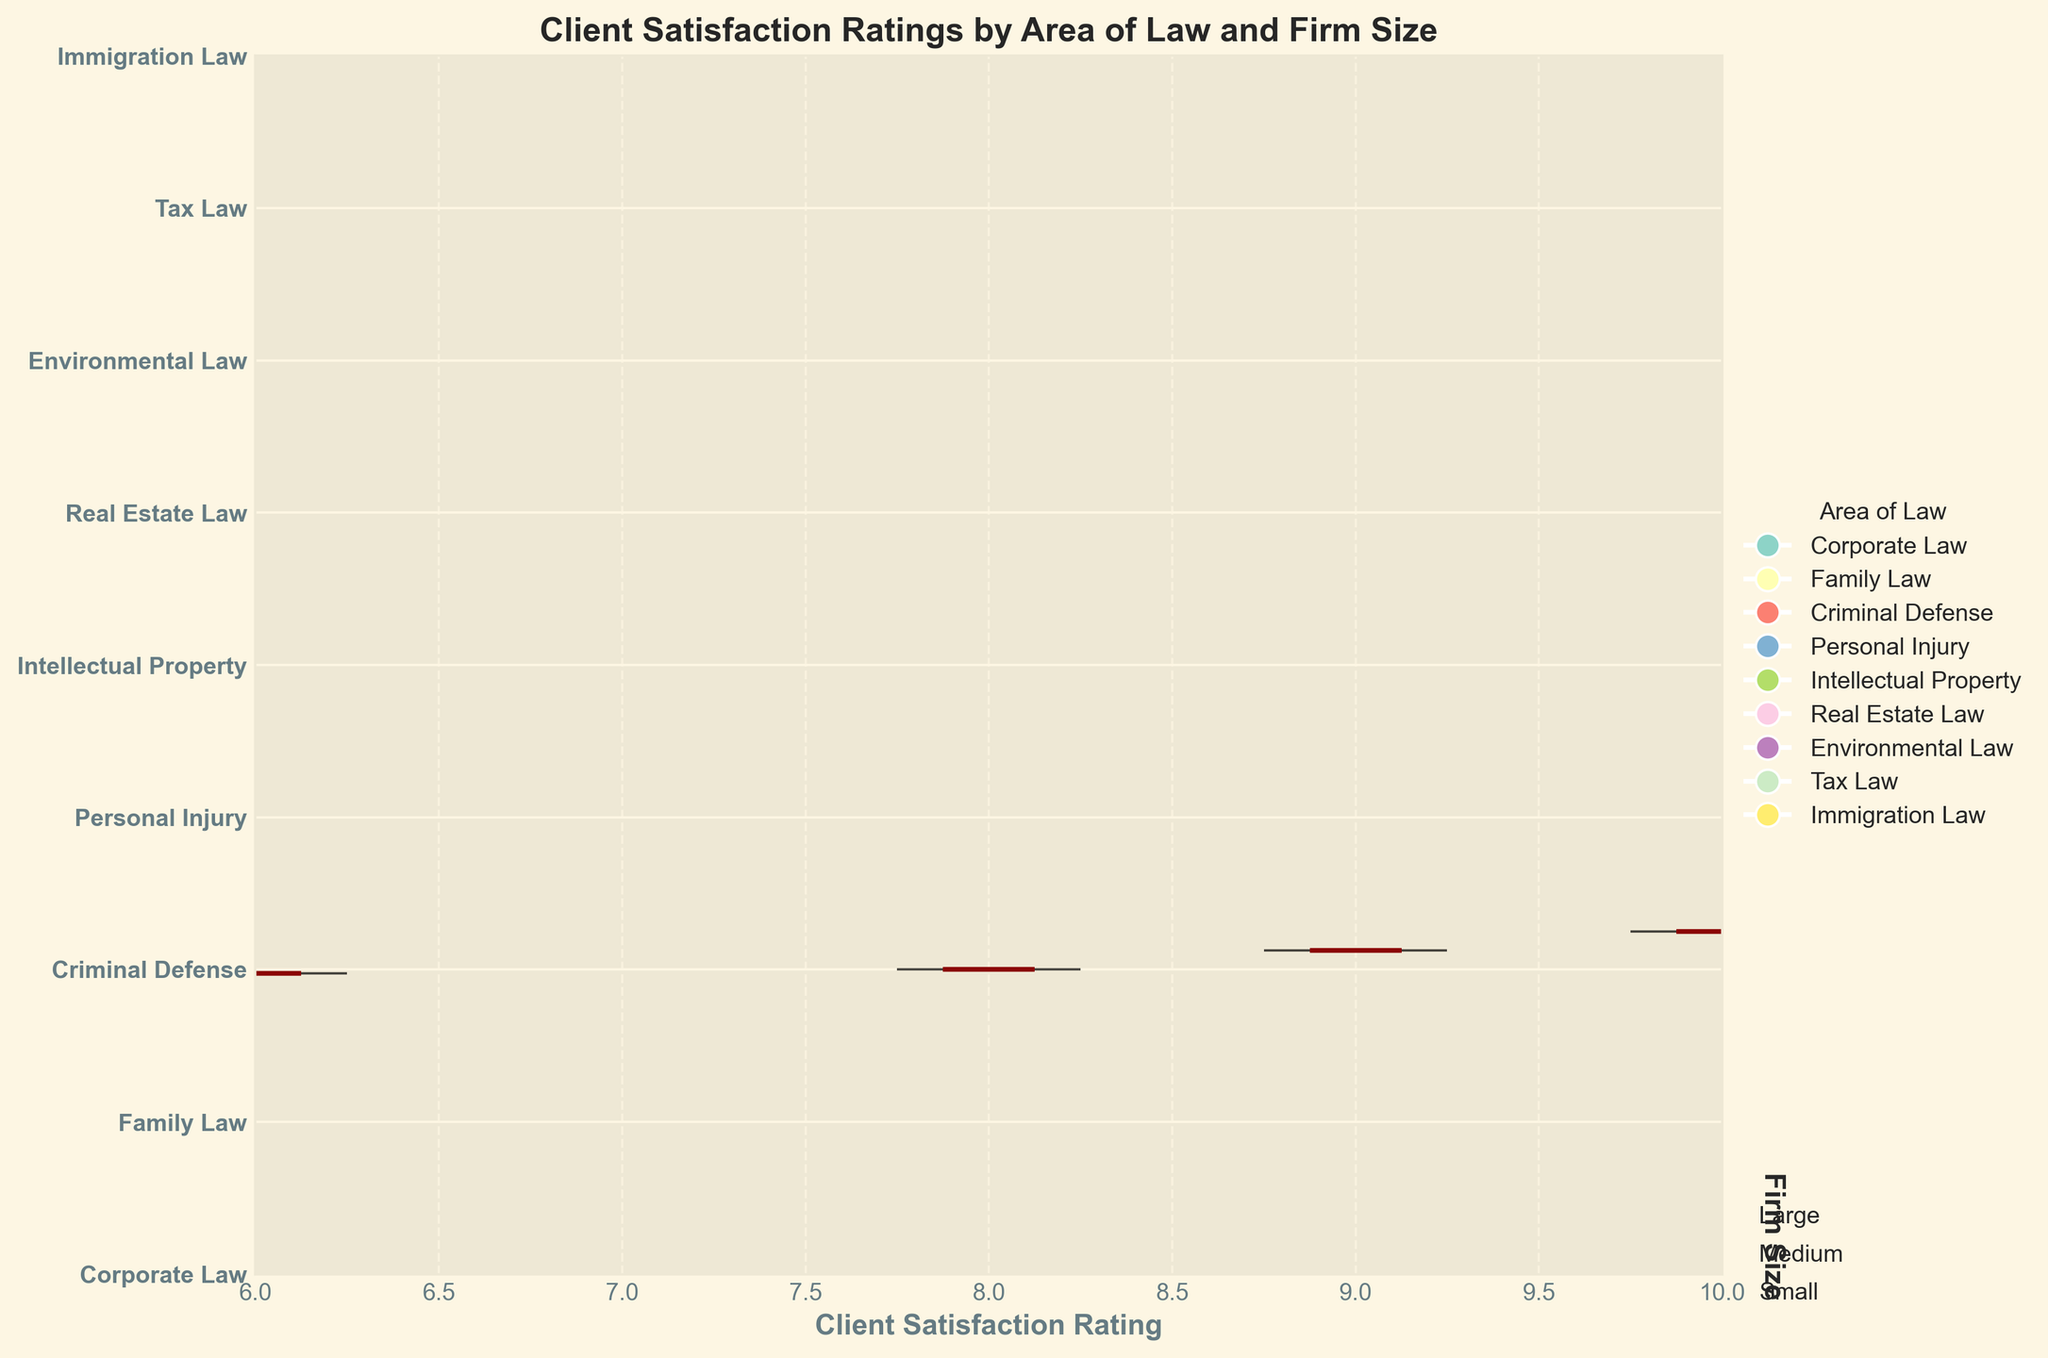What is the title of the figure? The title of the figure is located at the top center. It reads "Client Satisfaction Ratings by Area of Law and Firm Size".
Answer: Client Satisfaction Ratings by Area of Law and Firm Size What does the x-axis represent? The x-axis label is indicated at the bottom of the chart. It represents "Client Satisfaction Rating".
Answer: Client Satisfaction Rating Which area of law has the highest median client satisfaction rating for large firms? At the bottom segment of each area, there is a median indicator. For large firms, Criminal Defense shows the highest median satisfaction rating at 9.0.
Answer: Criminal Defense How many different colors are used in the figure, and what do they represent? By referencing the violin plots, each uniquely colored segment corresponds to a different area of law. Counting these, there are 10 distinct colors used in total. Each color represents a specific area of law as explained by the legend on the right side.
Answer: 10 What is the general trend in client satisfaction from small to large firms across all areas of law? Each group of violins shows three sizes (small, medium, large) moving from left to right. For almost all areas of law, the rating increases as the firm size increases, indicating a general trend of higher satisfaction with larger firms.
Answer: Increasing Compare the client satisfaction rating medians between Family Law and Tax Law for medium-sized firms. The medians for Family Law and Tax Law can be identified by the marks on their respective violin plots. Family Law has a median satisfaction rating of 7.4, while Tax Law has a median of 7.3 for medium-sized firms, making Family Law slightly higher.
Answer: Family Law What is the difference in client satisfaction rating between small and large firms in Real Estate Law? For Real Estate Law, the small firm median is 6.9, and the large firm median is 8.1. The difference is calculated as 8.1 - 6.9.
Answer: 1.2 Which area of law shows the least variation in client satisfaction ratings across all firm sizes? The variation can be visually assessed by the width and spread of each violin plot. Corporate Law, with relatively narrow and uniformly distributed violins across the sizes, shows the least variation.
Answer: Corporate Law What are the specific client satisfaction ratings for Intellectual Property in small, medium, and large firms? The data points directly refer to Intellectual Property: 7.8 for small firms, 8.3 for medium firms, and 8.8 for large firms.
Answer: 7.8, 8.3, 8.8 Is there any area of law where medium-sized firms have the highest client satisfaction ratings compared to small and large firms? By comparing all medians between small, medium, and large firm sizes in each area of law, it is noticeable that no area of law has a higher rating for medium firms over both small and large firms.
Answer: No 